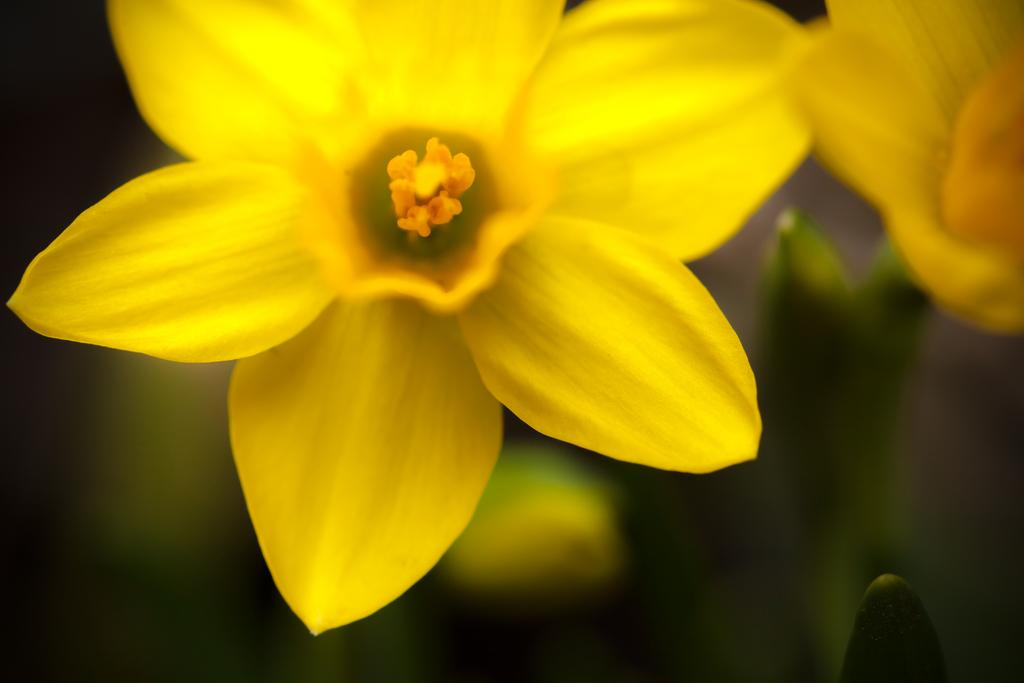What is the focus of the image? The image is zoomed in on a subject. What can be seen at the top of the image? There are yellow color flowers at the top of the image. How would you describe the background of the image? The background of the image is blurry. What else is visible in the image besides the flowers? The stems of the flowers are visible in the image. What type of team is shown working together in the image? There is no team present in the image; it features yellow color flowers and their stems. How does the mind of the flower appear in the image? The image does not depict the mind of the flower, as flowers do not have minds. 